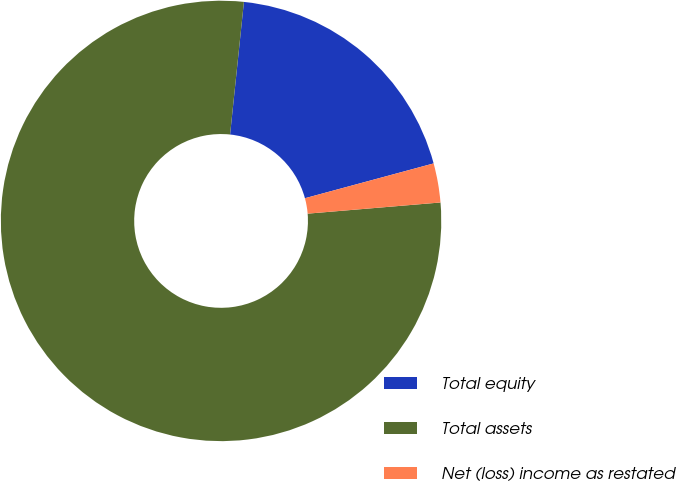Convert chart to OTSL. <chart><loc_0><loc_0><loc_500><loc_500><pie_chart><fcel>Total equity<fcel>Total assets<fcel>Net (loss) income as restated<nl><fcel>19.14%<fcel>77.99%<fcel>2.87%<nl></chart> 